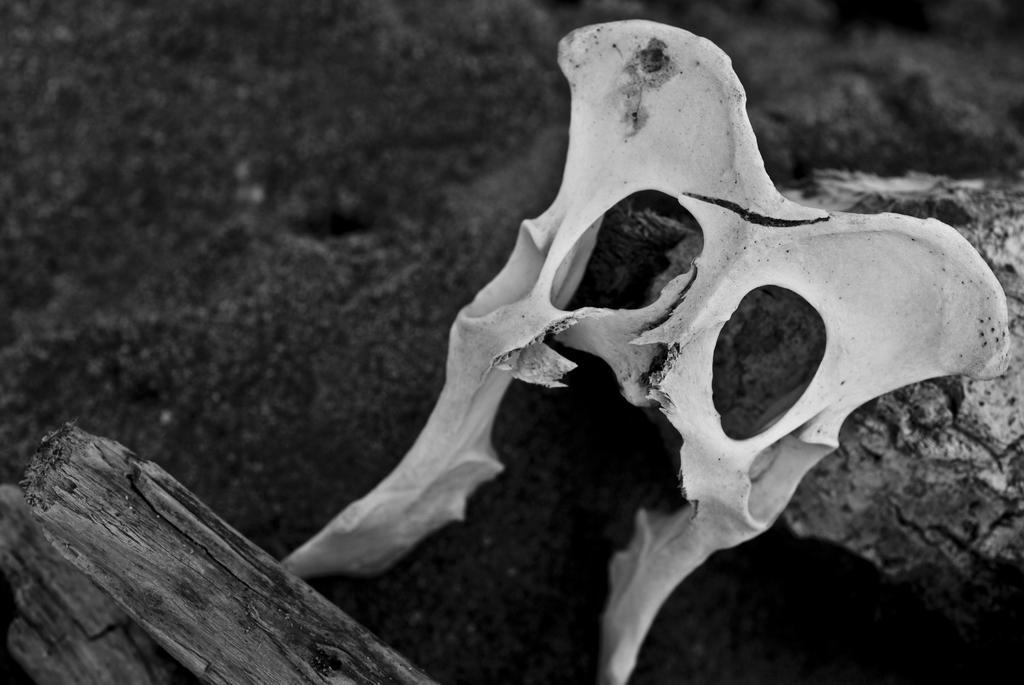What is the color scheme of the image? The image is black and white. What is the main subject of the image? There is a skull in the image. What other objects can be seen in the image? There is a wooden stick and a rock in the image. Where is the harbor located in the image? There is no harbor present in the image. What type of flame can be seen near the wooden stick in the image? There is no flame present in the image; it only features a skull, a wooden stick, and a rock. 